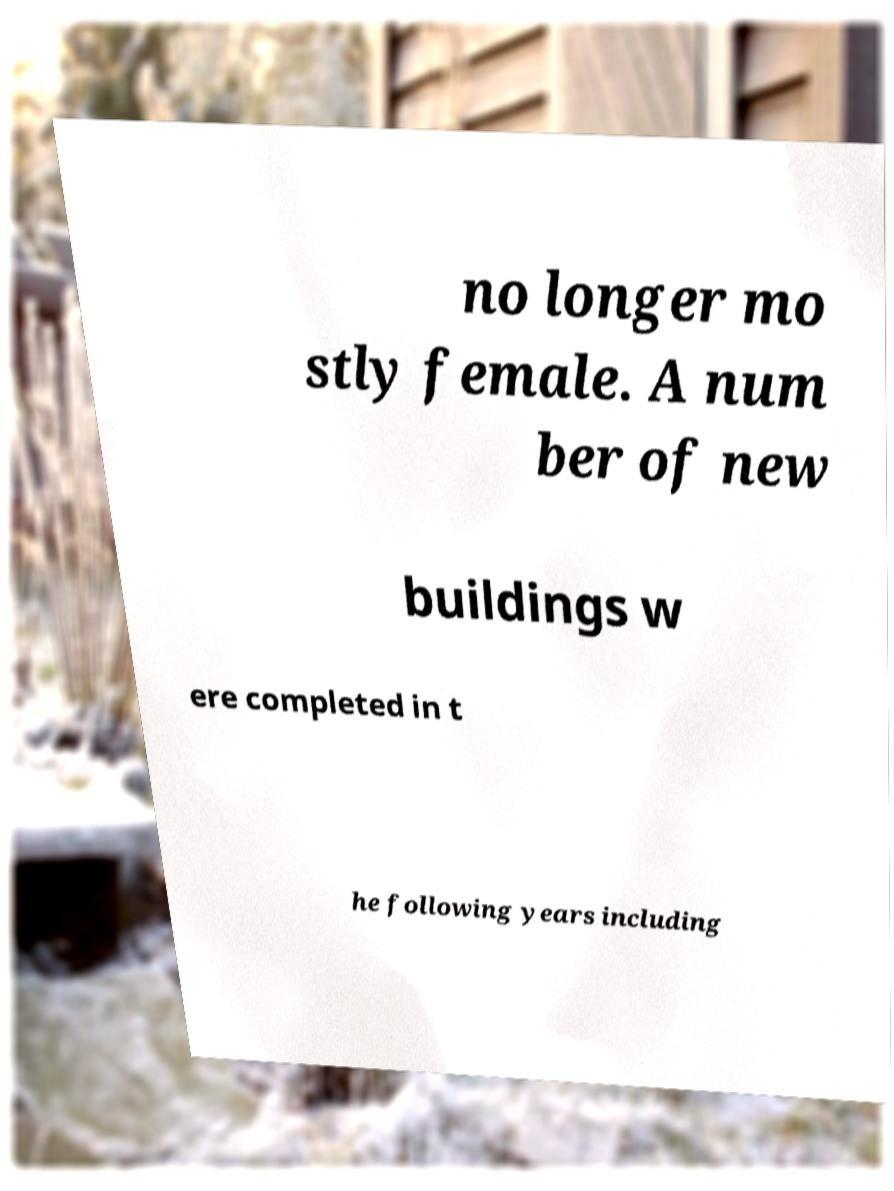Could you extract and type out the text from this image? no longer mo stly female. A num ber of new buildings w ere completed in t he following years including 